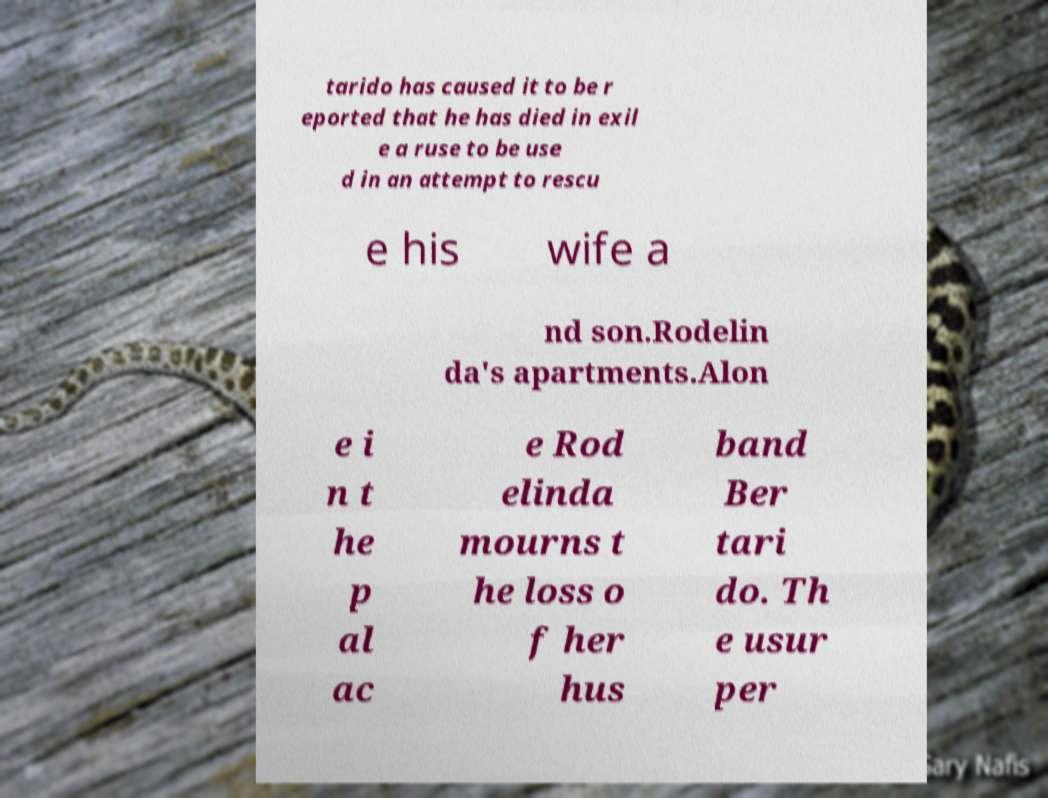For documentation purposes, I need the text within this image transcribed. Could you provide that? tarido has caused it to be r eported that he has died in exil e a ruse to be use d in an attempt to rescu e his wife a nd son.Rodelin da's apartments.Alon e i n t he p al ac e Rod elinda mourns t he loss o f her hus band Ber tari do. Th e usur per 